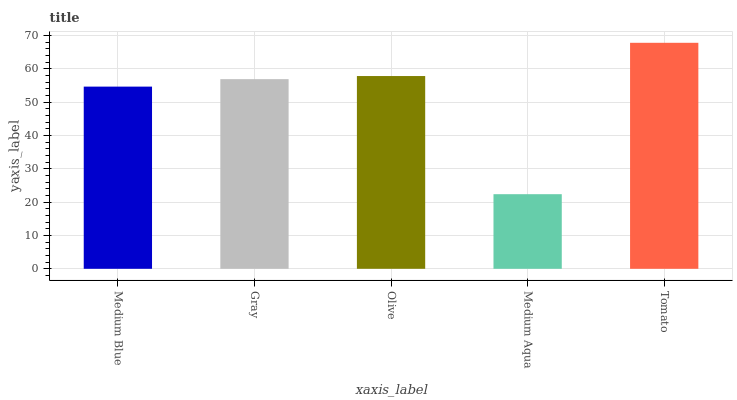Is Medium Aqua the minimum?
Answer yes or no. Yes. Is Tomato the maximum?
Answer yes or no. Yes. Is Gray the minimum?
Answer yes or no. No. Is Gray the maximum?
Answer yes or no. No. Is Gray greater than Medium Blue?
Answer yes or no. Yes. Is Medium Blue less than Gray?
Answer yes or no. Yes. Is Medium Blue greater than Gray?
Answer yes or no. No. Is Gray less than Medium Blue?
Answer yes or no. No. Is Gray the high median?
Answer yes or no. Yes. Is Gray the low median?
Answer yes or no. Yes. Is Olive the high median?
Answer yes or no. No. Is Tomato the low median?
Answer yes or no. No. 